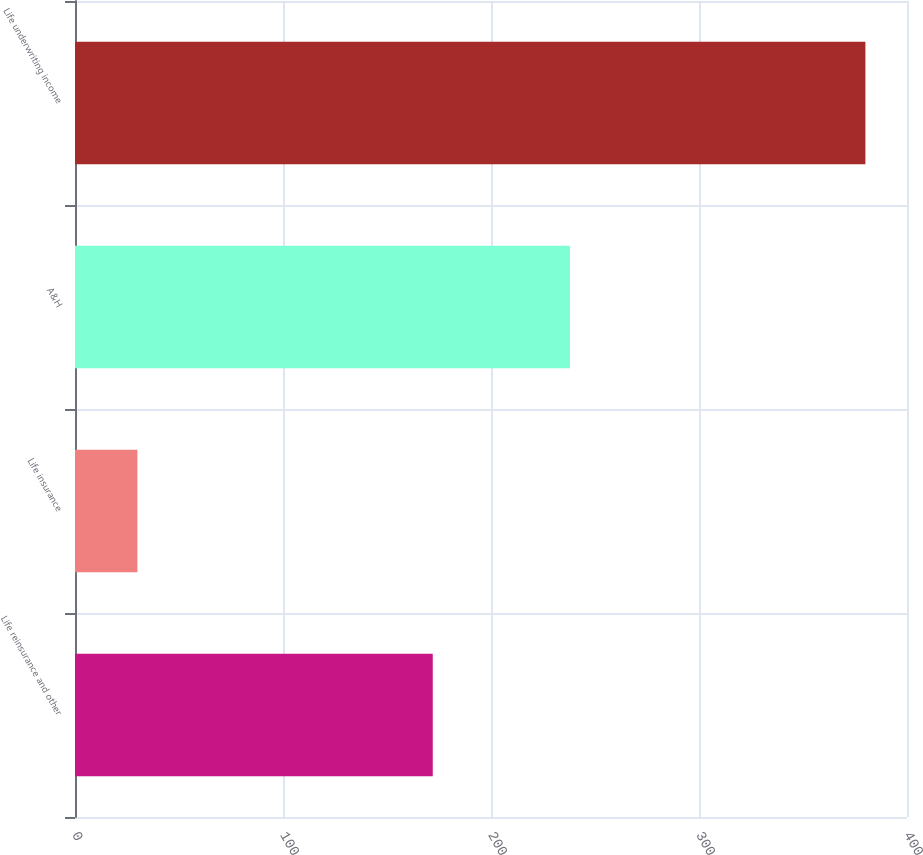Convert chart to OTSL. <chart><loc_0><loc_0><loc_500><loc_500><bar_chart><fcel>Life reinsurance and other<fcel>Life insurance<fcel>A&H<fcel>Life underwriting income<nl><fcel>172<fcel>30<fcel>238<fcel>380<nl></chart> 